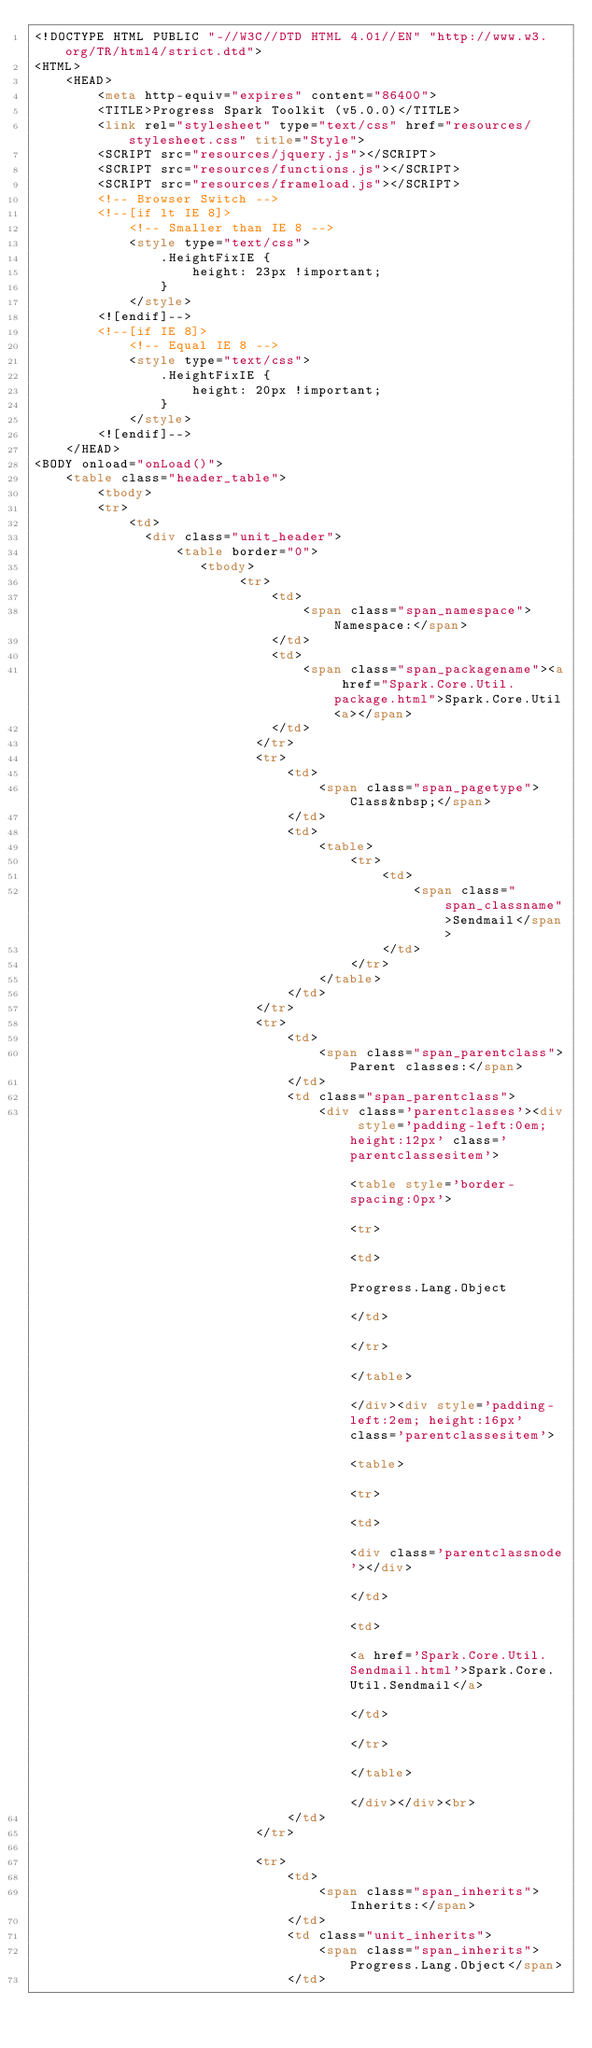Convert code to text. <code><loc_0><loc_0><loc_500><loc_500><_HTML_><!DOCTYPE HTML PUBLIC "-//W3C//DTD HTML 4.01//EN" "http://www.w3.org/TR/html4/strict.dtd">
<HTML>
    <HEAD>
        <meta http-equiv="expires" content="86400">
        <TITLE>Progress Spark Toolkit (v5.0.0)</TITLE>
        <link rel="stylesheet" type="text/css" href="resources/stylesheet.css" title="Style">
        <SCRIPT src="resources/jquery.js"></SCRIPT>
        <SCRIPT src="resources/functions.js"></SCRIPT>
        <SCRIPT src="resources/frameload.js"></SCRIPT>
        <!-- Browser Switch -->
        <!--[if lt IE 8]>
            <!-- Smaller than IE 8 -->
            <style type="text/css">
                .HeightFixIE { 
                    height: 23px !important;
                }
            </style>
        <![endif]-->
        <!--[if IE 8]>
            <!-- Equal IE 8 -->
            <style type="text/css">
                .HeightFixIE { 
                    height: 20px !important;
                }
            </style>
        <![endif]-->
    </HEAD>
<BODY onload="onLoad()">
    <table class="header_table">
        <tbody>
        <tr>
            <td>
            	<div class="unit_header">
            	    <table border="0">
            	       <tbody>
                	        <tr>
                	            <td>
                	                <span class="span_namespace">Namespace:</span>   
                	            </td>
                	            <td>
                	                <span class="span_packagename"><a href="Spark.Core.Util.package.html">Spark.Core.Util<a></span>
                	            </td>
                            </tr>
                            <tr>
                                <td>
                                    <span class="span_pagetype">Class&nbsp;</span>
                                </td>
                                <td>
                                    <table>
                                        <tr>
                                            <td>
                                                <span class="span_classname">Sendmail</span>
                                            </td>
                                        </tr>
                                    </table>
                                </td>
                            </tr>
                            <tr>
                                <td>
                                    <span class="span_parentclass">Parent classes:</span>   
                                </td>
                                <td class="span_parentclass">
                                    <div class='parentclasses'><div style='padding-left:0em; height:12px' class='parentclassesitem'>                                                            <table style='border-spacing:0px'>                                                                <tr>                                                                    <td>                                                                    Progress.Lang.Object                                                                    </td>                                                                </tr>                                                            </table>                                                       </div><div style='padding-left:2em; height:16px' class='parentclassesitem'>                                                                <table>                                                                    <tr>                                                                        <td>                                                                            <div class='parentclassnode'></div>                                                                        </td>                                                                        <td>                                                                        <a href='Spark.Core.Util.Sendmail.html'>Spark.Core.Util.Sendmail</a>                                                                        </td>                                                                    </tr>                                                                </table>                                                           </div></div><br>
                                </td>
                            </tr>
                            
                            <tr>
                                <td>
                                    <span class="span_inherits">Inherits:</span>
                                </td>
                                <td class="unit_inherits">
                                    <span class="span_inherits">Progress.Lang.Object</span>
                                </td></code> 